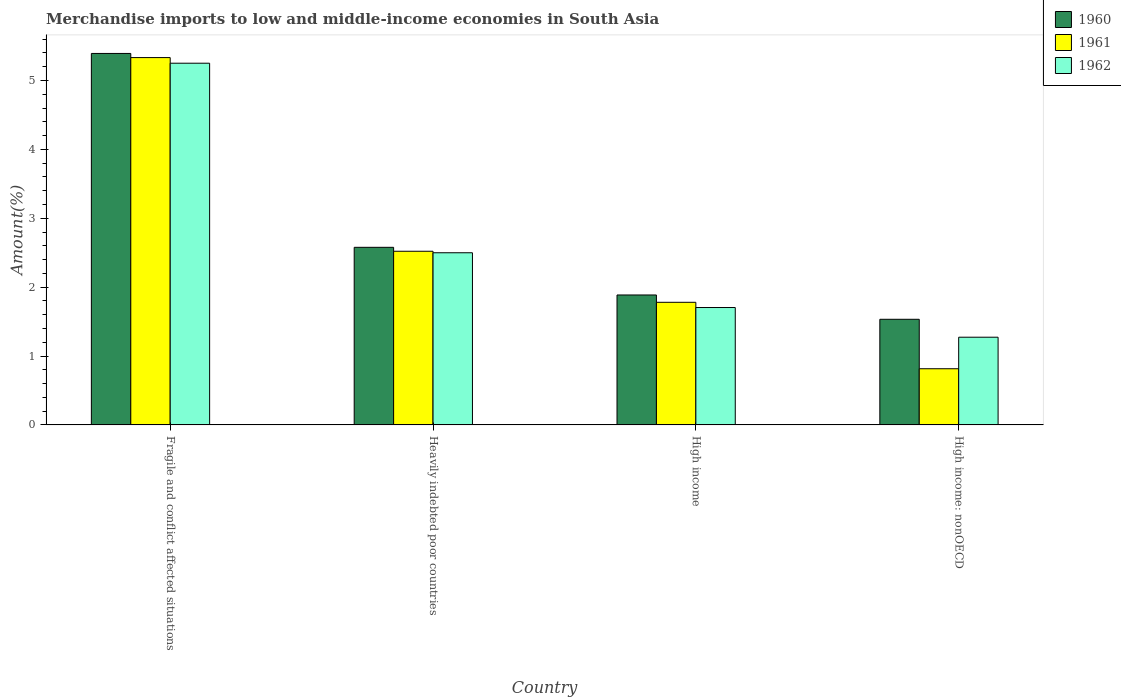How many groups of bars are there?
Keep it short and to the point. 4. Are the number of bars per tick equal to the number of legend labels?
Provide a succinct answer. Yes. How many bars are there on the 2nd tick from the right?
Make the answer very short. 3. In how many cases, is the number of bars for a given country not equal to the number of legend labels?
Make the answer very short. 0. What is the percentage of amount earned from merchandise imports in 1960 in High income: nonOECD?
Provide a succinct answer. 1.53. Across all countries, what is the maximum percentage of amount earned from merchandise imports in 1960?
Offer a very short reply. 5.39. Across all countries, what is the minimum percentage of amount earned from merchandise imports in 1961?
Provide a succinct answer. 0.82. In which country was the percentage of amount earned from merchandise imports in 1960 maximum?
Offer a very short reply. Fragile and conflict affected situations. In which country was the percentage of amount earned from merchandise imports in 1960 minimum?
Provide a short and direct response. High income: nonOECD. What is the total percentage of amount earned from merchandise imports in 1960 in the graph?
Provide a short and direct response. 11.39. What is the difference between the percentage of amount earned from merchandise imports in 1961 in Fragile and conflict affected situations and that in High income?
Ensure brevity in your answer.  3.55. What is the difference between the percentage of amount earned from merchandise imports in 1960 in High income and the percentage of amount earned from merchandise imports in 1962 in High income: nonOECD?
Provide a succinct answer. 0.61. What is the average percentage of amount earned from merchandise imports in 1961 per country?
Provide a succinct answer. 2.61. What is the difference between the percentage of amount earned from merchandise imports of/in 1961 and percentage of amount earned from merchandise imports of/in 1962 in Heavily indebted poor countries?
Your answer should be very brief. 0.02. In how many countries, is the percentage of amount earned from merchandise imports in 1961 greater than 2.8 %?
Offer a terse response. 1. What is the ratio of the percentage of amount earned from merchandise imports in 1960 in Fragile and conflict affected situations to that in Heavily indebted poor countries?
Provide a short and direct response. 2.09. Is the percentage of amount earned from merchandise imports in 1960 in Fragile and conflict affected situations less than that in Heavily indebted poor countries?
Your answer should be very brief. No. What is the difference between the highest and the second highest percentage of amount earned from merchandise imports in 1961?
Give a very brief answer. -0.74. What is the difference between the highest and the lowest percentage of amount earned from merchandise imports in 1962?
Your answer should be very brief. 3.98. In how many countries, is the percentage of amount earned from merchandise imports in 1962 greater than the average percentage of amount earned from merchandise imports in 1962 taken over all countries?
Your response must be concise. 1. Is the sum of the percentage of amount earned from merchandise imports in 1961 in Heavily indebted poor countries and High income greater than the maximum percentage of amount earned from merchandise imports in 1960 across all countries?
Provide a short and direct response. No. Is it the case that in every country, the sum of the percentage of amount earned from merchandise imports in 1960 and percentage of amount earned from merchandise imports in 1962 is greater than the percentage of amount earned from merchandise imports in 1961?
Ensure brevity in your answer.  Yes. What is the difference between two consecutive major ticks on the Y-axis?
Your answer should be very brief. 1. How many legend labels are there?
Offer a terse response. 3. How are the legend labels stacked?
Make the answer very short. Vertical. What is the title of the graph?
Offer a very short reply. Merchandise imports to low and middle-income economies in South Asia. Does "1983" appear as one of the legend labels in the graph?
Your answer should be compact. No. What is the label or title of the Y-axis?
Give a very brief answer. Amount(%). What is the Amount(%) of 1960 in Fragile and conflict affected situations?
Provide a succinct answer. 5.39. What is the Amount(%) of 1961 in Fragile and conflict affected situations?
Give a very brief answer. 5.33. What is the Amount(%) of 1962 in Fragile and conflict affected situations?
Your answer should be very brief. 5.25. What is the Amount(%) in 1960 in Heavily indebted poor countries?
Provide a short and direct response. 2.58. What is the Amount(%) of 1961 in Heavily indebted poor countries?
Your answer should be compact. 2.52. What is the Amount(%) of 1962 in Heavily indebted poor countries?
Offer a very short reply. 2.5. What is the Amount(%) in 1960 in High income?
Your answer should be compact. 1.89. What is the Amount(%) of 1961 in High income?
Provide a succinct answer. 1.78. What is the Amount(%) in 1962 in High income?
Ensure brevity in your answer.  1.7. What is the Amount(%) in 1960 in High income: nonOECD?
Your answer should be very brief. 1.53. What is the Amount(%) in 1961 in High income: nonOECD?
Ensure brevity in your answer.  0.82. What is the Amount(%) of 1962 in High income: nonOECD?
Provide a succinct answer. 1.27. Across all countries, what is the maximum Amount(%) in 1960?
Your response must be concise. 5.39. Across all countries, what is the maximum Amount(%) in 1961?
Make the answer very short. 5.33. Across all countries, what is the maximum Amount(%) of 1962?
Provide a succinct answer. 5.25. Across all countries, what is the minimum Amount(%) of 1960?
Offer a very short reply. 1.53. Across all countries, what is the minimum Amount(%) in 1961?
Provide a succinct answer. 0.82. Across all countries, what is the minimum Amount(%) in 1962?
Offer a very short reply. 1.27. What is the total Amount(%) in 1960 in the graph?
Offer a terse response. 11.39. What is the total Amount(%) of 1961 in the graph?
Ensure brevity in your answer.  10.45. What is the total Amount(%) in 1962 in the graph?
Provide a succinct answer. 10.73. What is the difference between the Amount(%) of 1960 in Fragile and conflict affected situations and that in Heavily indebted poor countries?
Your answer should be compact. 2.81. What is the difference between the Amount(%) in 1961 in Fragile and conflict affected situations and that in Heavily indebted poor countries?
Your answer should be very brief. 2.81. What is the difference between the Amount(%) of 1962 in Fragile and conflict affected situations and that in Heavily indebted poor countries?
Provide a succinct answer. 2.75. What is the difference between the Amount(%) in 1960 in Fragile and conflict affected situations and that in High income?
Ensure brevity in your answer.  3.51. What is the difference between the Amount(%) in 1961 in Fragile and conflict affected situations and that in High income?
Keep it short and to the point. 3.55. What is the difference between the Amount(%) of 1962 in Fragile and conflict affected situations and that in High income?
Give a very brief answer. 3.55. What is the difference between the Amount(%) in 1960 in Fragile and conflict affected situations and that in High income: nonOECD?
Provide a succinct answer. 3.86. What is the difference between the Amount(%) in 1961 in Fragile and conflict affected situations and that in High income: nonOECD?
Keep it short and to the point. 4.52. What is the difference between the Amount(%) in 1962 in Fragile and conflict affected situations and that in High income: nonOECD?
Ensure brevity in your answer.  3.98. What is the difference between the Amount(%) in 1960 in Heavily indebted poor countries and that in High income?
Offer a very short reply. 0.69. What is the difference between the Amount(%) in 1961 in Heavily indebted poor countries and that in High income?
Your response must be concise. 0.74. What is the difference between the Amount(%) in 1962 in Heavily indebted poor countries and that in High income?
Your response must be concise. 0.79. What is the difference between the Amount(%) of 1960 in Heavily indebted poor countries and that in High income: nonOECD?
Provide a succinct answer. 1.04. What is the difference between the Amount(%) of 1961 in Heavily indebted poor countries and that in High income: nonOECD?
Give a very brief answer. 1.71. What is the difference between the Amount(%) of 1962 in Heavily indebted poor countries and that in High income: nonOECD?
Give a very brief answer. 1.23. What is the difference between the Amount(%) in 1960 in High income and that in High income: nonOECD?
Your answer should be very brief. 0.35. What is the difference between the Amount(%) of 1961 in High income and that in High income: nonOECD?
Your answer should be compact. 0.96. What is the difference between the Amount(%) in 1962 in High income and that in High income: nonOECD?
Provide a short and direct response. 0.43. What is the difference between the Amount(%) of 1960 in Fragile and conflict affected situations and the Amount(%) of 1961 in Heavily indebted poor countries?
Provide a short and direct response. 2.87. What is the difference between the Amount(%) of 1960 in Fragile and conflict affected situations and the Amount(%) of 1962 in Heavily indebted poor countries?
Give a very brief answer. 2.89. What is the difference between the Amount(%) of 1961 in Fragile and conflict affected situations and the Amount(%) of 1962 in Heavily indebted poor countries?
Provide a short and direct response. 2.83. What is the difference between the Amount(%) in 1960 in Fragile and conflict affected situations and the Amount(%) in 1961 in High income?
Ensure brevity in your answer.  3.61. What is the difference between the Amount(%) of 1960 in Fragile and conflict affected situations and the Amount(%) of 1962 in High income?
Offer a very short reply. 3.69. What is the difference between the Amount(%) of 1961 in Fragile and conflict affected situations and the Amount(%) of 1962 in High income?
Offer a very short reply. 3.63. What is the difference between the Amount(%) of 1960 in Fragile and conflict affected situations and the Amount(%) of 1961 in High income: nonOECD?
Provide a short and direct response. 4.58. What is the difference between the Amount(%) in 1960 in Fragile and conflict affected situations and the Amount(%) in 1962 in High income: nonOECD?
Provide a succinct answer. 4.12. What is the difference between the Amount(%) in 1961 in Fragile and conflict affected situations and the Amount(%) in 1962 in High income: nonOECD?
Offer a very short reply. 4.06. What is the difference between the Amount(%) in 1960 in Heavily indebted poor countries and the Amount(%) in 1961 in High income?
Offer a very short reply. 0.8. What is the difference between the Amount(%) of 1960 in Heavily indebted poor countries and the Amount(%) of 1962 in High income?
Offer a terse response. 0.87. What is the difference between the Amount(%) in 1961 in Heavily indebted poor countries and the Amount(%) in 1962 in High income?
Make the answer very short. 0.82. What is the difference between the Amount(%) of 1960 in Heavily indebted poor countries and the Amount(%) of 1961 in High income: nonOECD?
Your answer should be very brief. 1.76. What is the difference between the Amount(%) of 1960 in Heavily indebted poor countries and the Amount(%) of 1962 in High income: nonOECD?
Make the answer very short. 1.3. What is the difference between the Amount(%) of 1961 in Heavily indebted poor countries and the Amount(%) of 1962 in High income: nonOECD?
Make the answer very short. 1.25. What is the difference between the Amount(%) in 1960 in High income and the Amount(%) in 1961 in High income: nonOECD?
Your response must be concise. 1.07. What is the difference between the Amount(%) in 1960 in High income and the Amount(%) in 1962 in High income: nonOECD?
Offer a very short reply. 0.61. What is the difference between the Amount(%) of 1961 in High income and the Amount(%) of 1962 in High income: nonOECD?
Make the answer very short. 0.51. What is the average Amount(%) in 1960 per country?
Make the answer very short. 2.85. What is the average Amount(%) of 1961 per country?
Offer a terse response. 2.61. What is the average Amount(%) in 1962 per country?
Your answer should be compact. 2.68. What is the difference between the Amount(%) in 1960 and Amount(%) in 1961 in Fragile and conflict affected situations?
Your answer should be very brief. 0.06. What is the difference between the Amount(%) in 1960 and Amount(%) in 1962 in Fragile and conflict affected situations?
Ensure brevity in your answer.  0.14. What is the difference between the Amount(%) in 1961 and Amount(%) in 1962 in Fragile and conflict affected situations?
Offer a terse response. 0.08. What is the difference between the Amount(%) in 1960 and Amount(%) in 1961 in Heavily indebted poor countries?
Offer a terse response. 0.06. What is the difference between the Amount(%) of 1960 and Amount(%) of 1962 in Heavily indebted poor countries?
Give a very brief answer. 0.08. What is the difference between the Amount(%) of 1961 and Amount(%) of 1962 in Heavily indebted poor countries?
Make the answer very short. 0.02. What is the difference between the Amount(%) in 1960 and Amount(%) in 1961 in High income?
Provide a short and direct response. 0.11. What is the difference between the Amount(%) of 1960 and Amount(%) of 1962 in High income?
Make the answer very short. 0.18. What is the difference between the Amount(%) in 1961 and Amount(%) in 1962 in High income?
Offer a terse response. 0.08. What is the difference between the Amount(%) in 1960 and Amount(%) in 1961 in High income: nonOECD?
Ensure brevity in your answer.  0.72. What is the difference between the Amount(%) of 1960 and Amount(%) of 1962 in High income: nonOECD?
Provide a short and direct response. 0.26. What is the difference between the Amount(%) in 1961 and Amount(%) in 1962 in High income: nonOECD?
Keep it short and to the point. -0.46. What is the ratio of the Amount(%) in 1960 in Fragile and conflict affected situations to that in Heavily indebted poor countries?
Keep it short and to the point. 2.09. What is the ratio of the Amount(%) of 1961 in Fragile and conflict affected situations to that in Heavily indebted poor countries?
Make the answer very short. 2.12. What is the ratio of the Amount(%) in 1962 in Fragile and conflict affected situations to that in Heavily indebted poor countries?
Your answer should be very brief. 2.1. What is the ratio of the Amount(%) of 1960 in Fragile and conflict affected situations to that in High income?
Ensure brevity in your answer.  2.86. What is the ratio of the Amount(%) in 1961 in Fragile and conflict affected situations to that in High income?
Provide a succinct answer. 3. What is the ratio of the Amount(%) in 1962 in Fragile and conflict affected situations to that in High income?
Keep it short and to the point. 3.08. What is the ratio of the Amount(%) in 1960 in Fragile and conflict affected situations to that in High income: nonOECD?
Ensure brevity in your answer.  3.52. What is the ratio of the Amount(%) of 1961 in Fragile and conflict affected situations to that in High income: nonOECD?
Your response must be concise. 6.54. What is the ratio of the Amount(%) in 1962 in Fragile and conflict affected situations to that in High income: nonOECD?
Offer a terse response. 4.12. What is the ratio of the Amount(%) of 1960 in Heavily indebted poor countries to that in High income?
Keep it short and to the point. 1.37. What is the ratio of the Amount(%) of 1961 in Heavily indebted poor countries to that in High income?
Your response must be concise. 1.42. What is the ratio of the Amount(%) of 1962 in Heavily indebted poor countries to that in High income?
Ensure brevity in your answer.  1.47. What is the ratio of the Amount(%) in 1960 in Heavily indebted poor countries to that in High income: nonOECD?
Your answer should be compact. 1.68. What is the ratio of the Amount(%) of 1961 in Heavily indebted poor countries to that in High income: nonOECD?
Offer a terse response. 3.09. What is the ratio of the Amount(%) in 1962 in Heavily indebted poor countries to that in High income: nonOECD?
Give a very brief answer. 1.96. What is the ratio of the Amount(%) in 1960 in High income to that in High income: nonOECD?
Offer a very short reply. 1.23. What is the ratio of the Amount(%) of 1961 in High income to that in High income: nonOECD?
Your answer should be compact. 2.18. What is the ratio of the Amount(%) in 1962 in High income to that in High income: nonOECD?
Make the answer very short. 1.34. What is the difference between the highest and the second highest Amount(%) in 1960?
Ensure brevity in your answer.  2.81. What is the difference between the highest and the second highest Amount(%) of 1961?
Provide a short and direct response. 2.81. What is the difference between the highest and the second highest Amount(%) of 1962?
Offer a very short reply. 2.75. What is the difference between the highest and the lowest Amount(%) of 1960?
Provide a short and direct response. 3.86. What is the difference between the highest and the lowest Amount(%) in 1961?
Keep it short and to the point. 4.52. What is the difference between the highest and the lowest Amount(%) of 1962?
Provide a short and direct response. 3.98. 